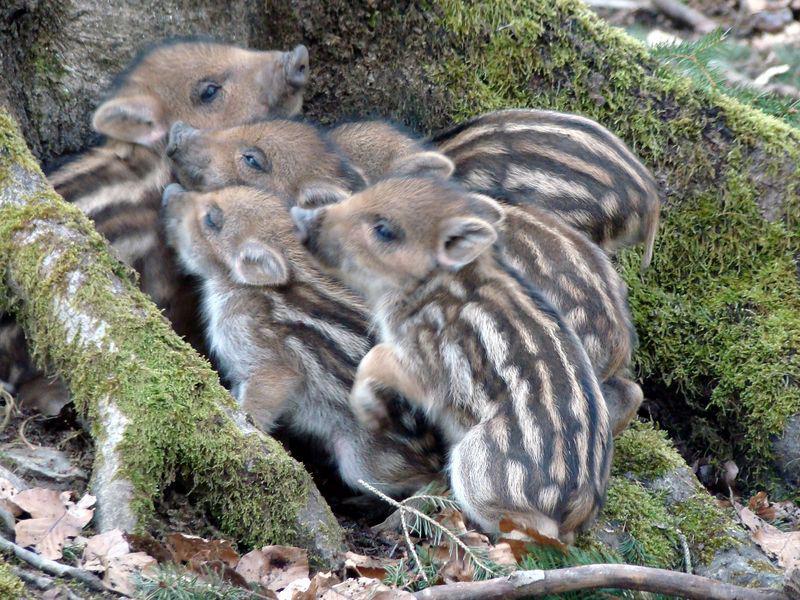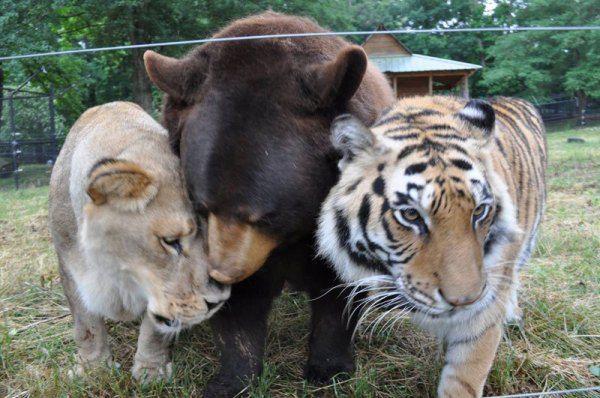The first image is the image on the left, the second image is the image on the right. Evaluate the accuracy of this statement regarding the images: "Both images contain only piglets". Is it true? Answer yes or no. No. 